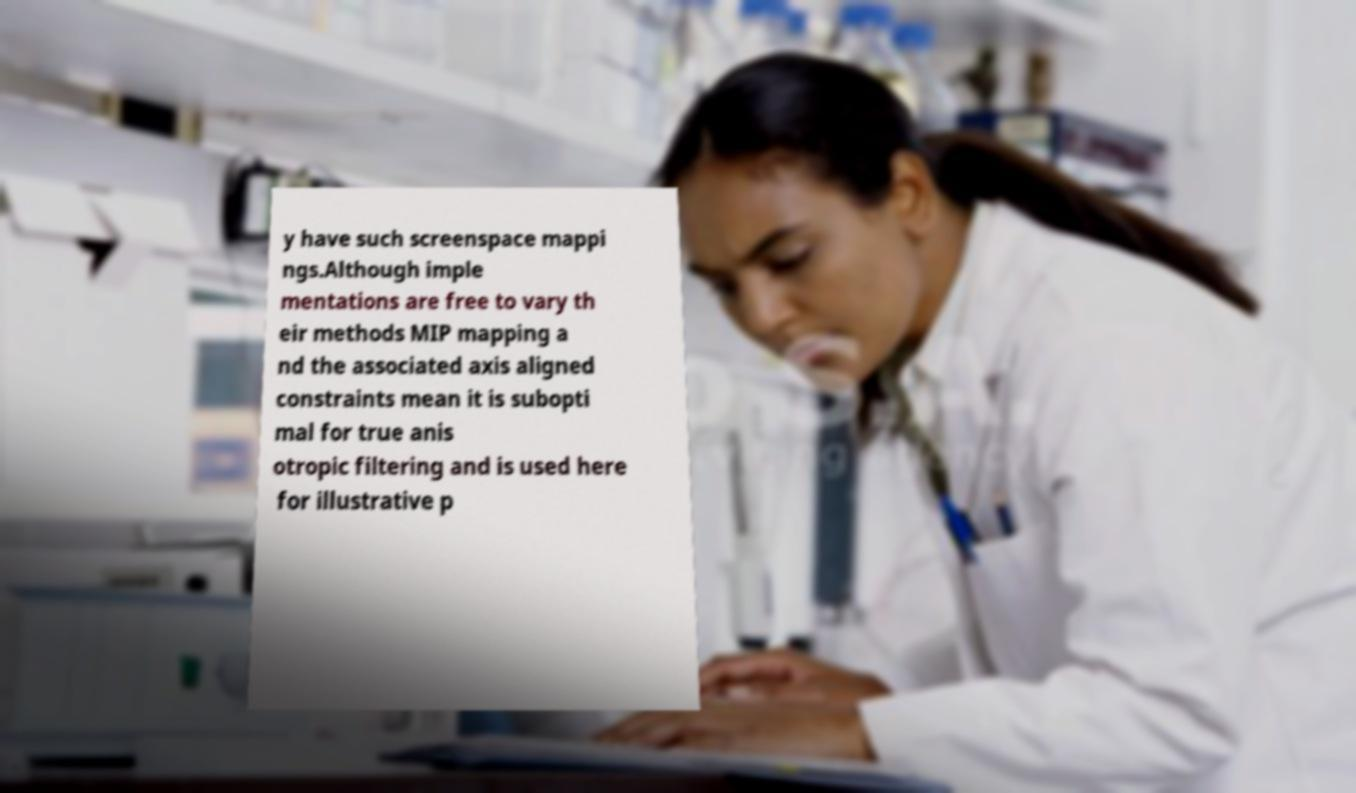There's text embedded in this image that I need extracted. Can you transcribe it verbatim? y have such screenspace mappi ngs.Although imple mentations are free to vary th eir methods MIP mapping a nd the associated axis aligned constraints mean it is subopti mal for true anis otropic filtering and is used here for illustrative p 